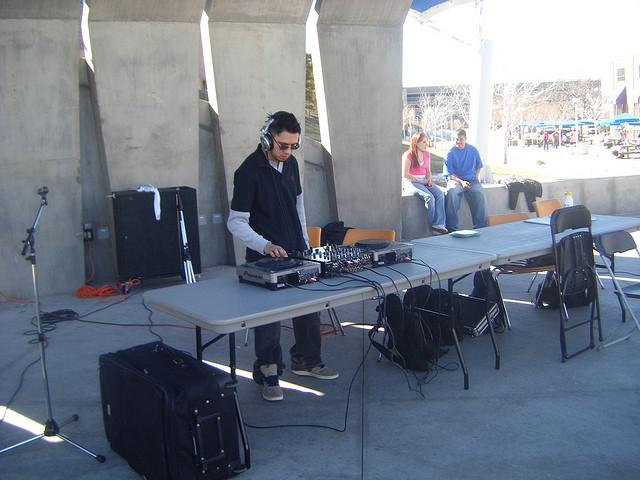How many chairs are around the table?
Quick response, please. 6. Is this a concert?
Be succinct. Yes. What color are the umbrellas in the distance?
Give a very brief answer. Blue. 